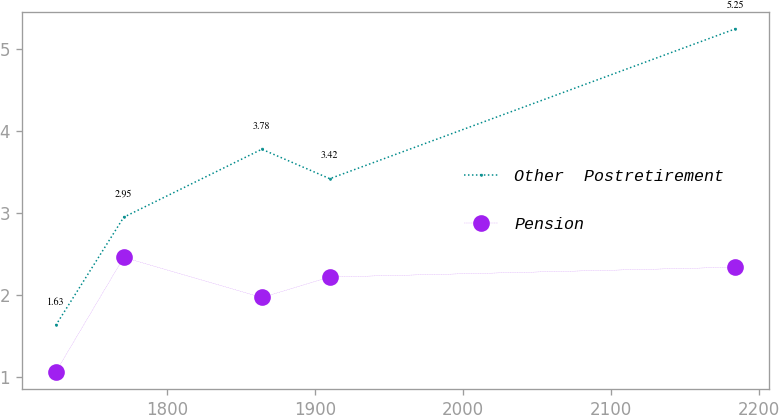<chart> <loc_0><loc_0><loc_500><loc_500><line_chart><ecel><fcel>Other  Postretirement<fcel>Pension<nl><fcel>1724.91<fcel>1.63<fcel>1.06<nl><fcel>1770.86<fcel>2.95<fcel>2.46<nl><fcel>1864.2<fcel>3.78<fcel>1.97<nl><fcel>1910.15<fcel>3.42<fcel>2.22<nl><fcel>2184.38<fcel>5.25<fcel>2.34<nl></chart> 